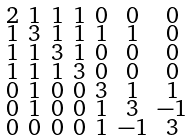Convert formula to latex. <formula><loc_0><loc_0><loc_500><loc_500>\begin{smallmatrix} 2 & 1 & 1 & 1 & 0 & 0 & 0 \\ 1 & 3 & 1 & 1 & 1 & 1 & 0 \\ 1 & 1 & 3 & 1 & 0 & 0 & 0 \\ 1 & 1 & 1 & 3 & 0 & 0 & 0 \\ 0 & 1 & 0 & 0 & 3 & 1 & 1 \\ 0 & 1 & 0 & 0 & 1 & 3 & - 1 \\ 0 & 0 & 0 & 0 & 1 & - 1 & 3 \end{smallmatrix}</formula> 